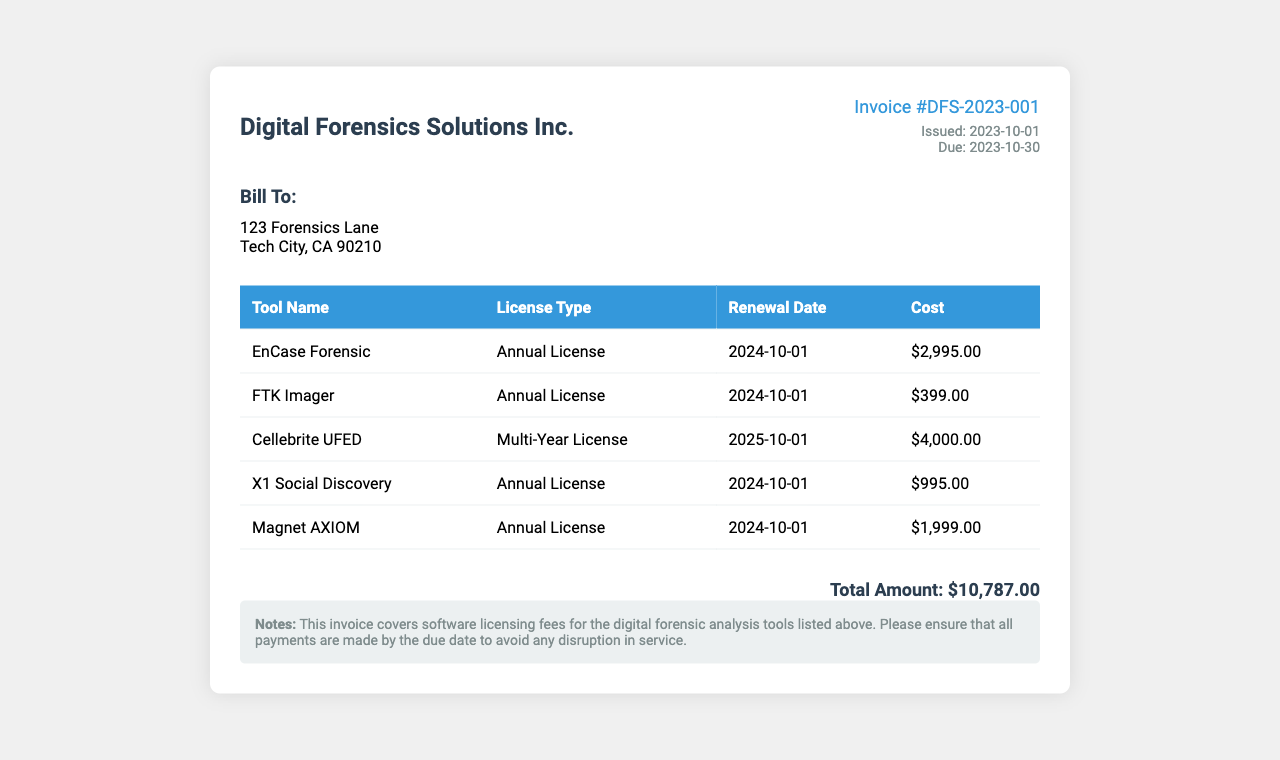What is the total amount due? The total amount due is listed at the bottom of the invoice, which is the combined cost of all software licenses.
Answer: $10,787.00 When is the invoice due? The due date for the invoice is specified under the invoice details section.
Answer: 2023-10-30 What is the license type for EnCase Forensic? The license type for EnCase Forensic is listed in the table under its respective row.
Answer: Annual License How much does Magnet AXIOM cost? The cost for Magnet AXIOM is found in the table beside its name.
Answer: $1,999.00 What is the renewal date for FTK Imager? The renewal date for FTK Imager is shown in the corresponding row of the table.
Answer: 2024-10-01 Which software has a renewal date in 2025? The software with a renewal date in 2025 can be determined by checking the renewal dates in the table.
Answer: Cellebrite UFED What is the issued date of the invoice? The issued date is provided in the invoice details section.
Answer: 2023-10-01 How many annual licenses are listed in the document? To find the number of annual licenses, one must count the relevant licenses in the table.
Answer: Four 